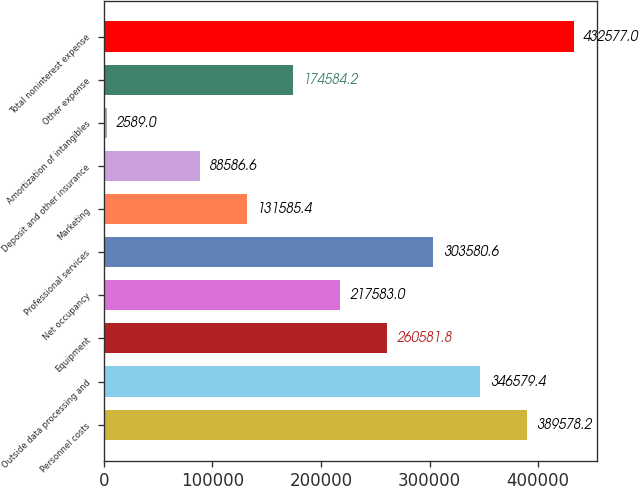Convert chart. <chart><loc_0><loc_0><loc_500><loc_500><bar_chart><fcel>Personnel costs<fcel>Outside data processing and<fcel>Equipment<fcel>Net occupancy<fcel>Professional services<fcel>Marketing<fcel>Deposit and other insurance<fcel>Amortization of intangibles<fcel>Other expense<fcel>Total noninterest expense<nl><fcel>389578<fcel>346579<fcel>260582<fcel>217583<fcel>303581<fcel>131585<fcel>88586.6<fcel>2589<fcel>174584<fcel>432577<nl></chart> 